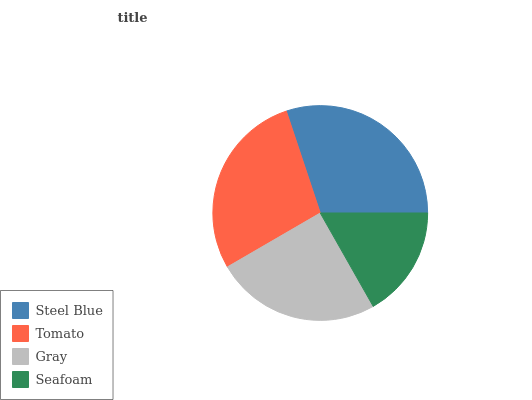Is Seafoam the minimum?
Answer yes or no. Yes. Is Steel Blue the maximum?
Answer yes or no. Yes. Is Tomato the minimum?
Answer yes or no. No. Is Tomato the maximum?
Answer yes or no. No. Is Steel Blue greater than Tomato?
Answer yes or no. Yes. Is Tomato less than Steel Blue?
Answer yes or no. Yes. Is Tomato greater than Steel Blue?
Answer yes or no. No. Is Steel Blue less than Tomato?
Answer yes or no. No. Is Tomato the high median?
Answer yes or no. Yes. Is Gray the low median?
Answer yes or no. Yes. Is Steel Blue the high median?
Answer yes or no. No. Is Steel Blue the low median?
Answer yes or no. No. 